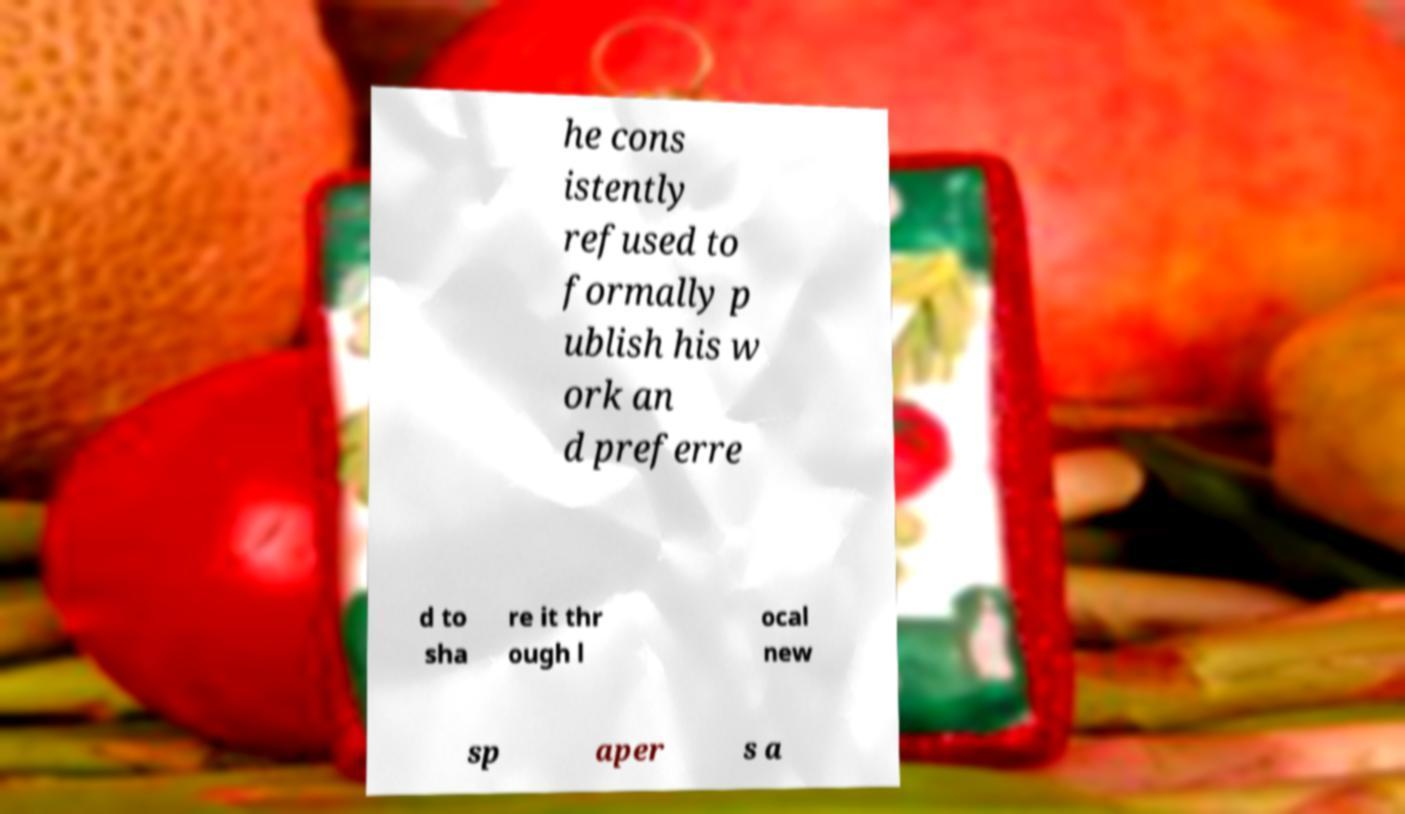Can you accurately transcribe the text from the provided image for me? he cons istently refused to formally p ublish his w ork an d preferre d to sha re it thr ough l ocal new sp aper s a 